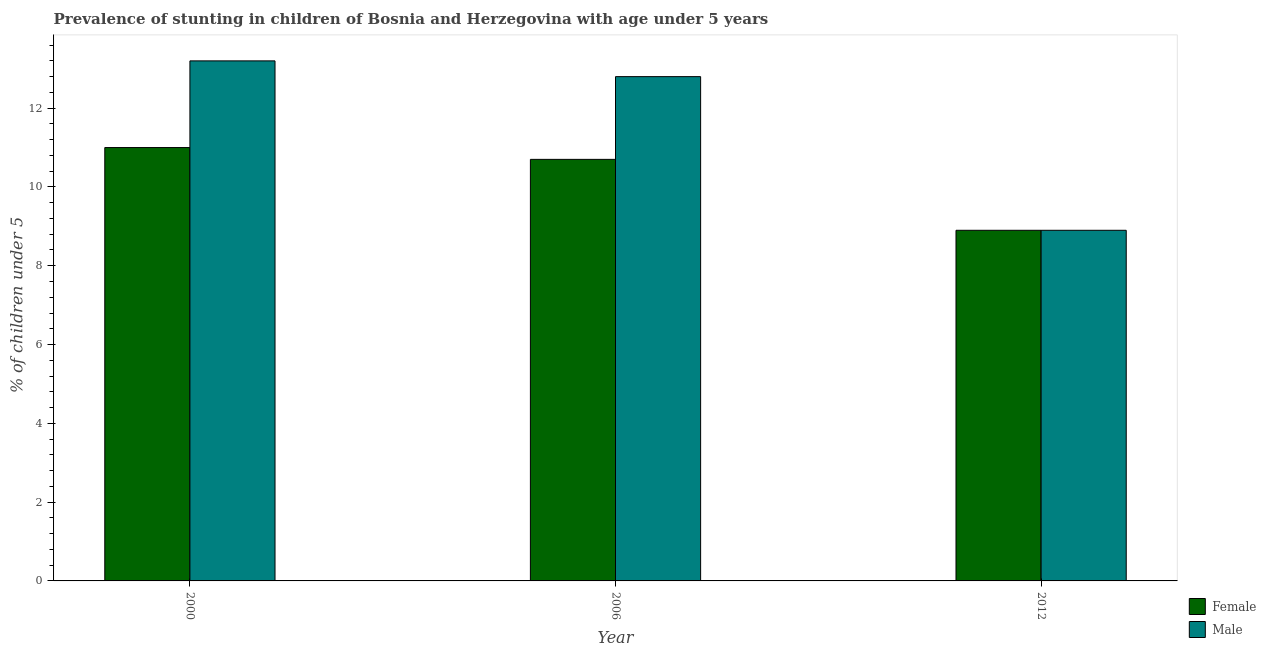How many different coloured bars are there?
Your response must be concise. 2. How many groups of bars are there?
Provide a succinct answer. 3. Are the number of bars per tick equal to the number of legend labels?
Give a very brief answer. Yes. Are the number of bars on each tick of the X-axis equal?
Your response must be concise. Yes. What is the percentage of stunted female children in 2000?
Make the answer very short. 11. Across all years, what is the maximum percentage of stunted male children?
Your answer should be compact. 13.2. Across all years, what is the minimum percentage of stunted female children?
Provide a short and direct response. 8.9. What is the total percentage of stunted male children in the graph?
Offer a very short reply. 34.9. What is the difference between the percentage of stunted male children in 2006 and that in 2012?
Provide a succinct answer. 3.9. What is the difference between the percentage of stunted male children in 2012 and the percentage of stunted female children in 2006?
Your answer should be compact. -3.9. What is the average percentage of stunted male children per year?
Your answer should be compact. 11.63. In the year 2006, what is the difference between the percentage of stunted female children and percentage of stunted male children?
Make the answer very short. 0. What is the ratio of the percentage of stunted female children in 2000 to that in 2012?
Your answer should be compact. 1.24. Is the difference between the percentage of stunted female children in 2006 and 2012 greater than the difference between the percentage of stunted male children in 2006 and 2012?
Keep it short and to the point. No. What is the difference between the highest and the second highest percentage of stunted female children?
Give a very brief answer. 0.3. What is the difference between the highest and the lowest percentage of stunted male children?
Provide a succinct answer. 4.3. In how many years, is the percentage of stunted female children greater than the average percentage of stunted female children taken over all years?
Keep it short and to the point. 2. Is the sum of the percentage of stunted female children in 2006 and 2012 greater than the maximum percentage of stunted male children across all years?
Ensure brevity in your answer.  Yes. What does the 1st bar from the left in 2006 represents?
Your response must be concise. Female. How many bars are there?
Make the answer very short. 6. Are the values on the major ticks of Y-axis written in scientific E-notation?
Give a very brief answer. No. Does the graph contain any zero values?
Provide a short and direct response. No. What is the title of the graph?
Your answer should be very brief. Prevalence of stunting in children of Bosnia and Herzegovina with age under 5 years. Does "UN agencies" appear as one of the legend labels in the graph?
Your answer should be very brief. No. What is the label or title of the Y-axis?
Provide a succinct answer.  % of children under 5. What is the  % of children under 5 in Female in 2000?
Provide a succinct answer. 11. What is the  % of children under 5 in Male in 2000?
Provide a succinct answer. 13.2. What is the  % of children under 5 of Female in 2006?
Provide a short and direct response. 10.7. What is the  % of children under 5 in Male in 2006?
Your answer should be very brief. 12.8. What is the  % of children under 5 in Female in 2012?
Provide a succinct answer. 8.9. What is the  % of children under 5 in Male in 2012?
Offer a terse response. 8.9. Across all years, what is the maximum  % of children under 5 of Male?
Keep it short and to the point. 13.2. Across all years, what is the minimum  % of children under 5 in Female?
Your answer should be compact. 8.9. Across all years, what is the minimum  % of children under 5 in Male?
Ensure brevity in your answer.  8.9. What is the total  % of children under 5 in Female in the graph?
Provide a succinct answer. 30.6. What is the total  % of children under 5 of Male in the graph?
Offer a terse response. 34.9. What is the difference between the  % of children under 5 of Male in 2000 and that in 2006?
Offer a very short reply. 0.4. What is the difference between the  % of children under 5 of Female in 2000 and that in 2012?
Provide a succinct answer. 2.1. What is the difference between the  % of children under 5 of Male in 2000 and that in 2012?
Your answer should be compact. 4.3. What is the difference between the  % of children under 5 in Female in 2006 and that in 2012?
Your response must be concise. 1.8. What is the difference between the  % of children under 5 of Male in 2006 and that in 2012?
Give a very brief answer. 3.9. What is the difference between the  % of children under 5 in Female in 2000 and the  % of children under 5 in Male in 2006?
Offer a terse response. -1.8. What is the difference between the  % of children under 5 in Female in 2000 and the  % of children under 5 in Male in 2012?
Give a very brief answer. 2.1. What is the difference between the  % of children under 5 in Female in 2006 and the  % of children under 5 in Male in 2012?
Ensure brevity in your answer.  1.8. What is the average  % of children under 5 in Female per year?
Offer a terse response. 10.2. What is the average  % of children under 5 in Male per year?
Ensure brevity in your answer.  11.63. In the year 2000, what is the difference between the  % of children under 5 in Female and  % of children under 5 in Male?
Give a very brief answer. -2.2. In the year 2006, what is the difference between the  % of children under 5 of Female and  % of children under 5 of Male?
Make the answer very short. -2.1. What is the ratio of the  % of children under 5 of Female in 2000 to that in 2006?
Provide a short and direct response. 1.03. What is the ratio of the  % of children under 5 of Male in 2000 to that in 2006?
Give a very brief answer. 1.03. What is the ratio of the  % of children under 5 of Female in 2000 to that in 2012?
Keep it short and to the point. 1.24. What is the ratio of the  % of children under 5 of Male in 2000 to that in 2012?
Give a very brief answer. 1.48. What is the ratio of the  % of children under 5 of Female in 2006 to that in 2012?
Offer a very short reply. 1.2. What is the ratio of the  % of children under 5 of Male in 2006 to that in 2012?
Make the answer very short. 1.44. What is the difference between the highest and the second highest  % of children under 5 of Male?
Offer a terse response. 0.4. What is the difference between the highest and the lowest  % of children under 5 of Female?
Offer a very short reply. 2.1. What is the difference between the highest and the lowest  % of children under 5 in Male?
Your answer should be very brief. 4.3. 